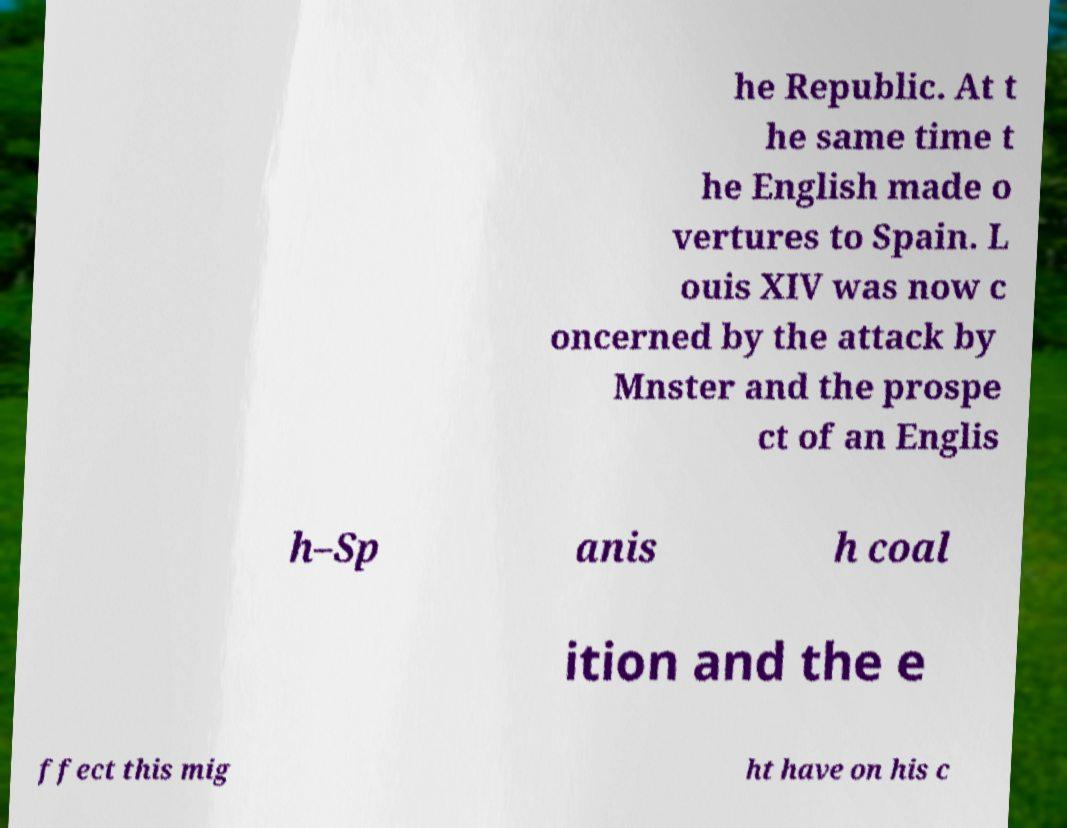There's text embedded in this image that I need extracted. Can you transcribe it verbatim? he Republic. At t he same time t he English made o vertures to Spain. L ouis XIV was now c oncerned by the attack by Mnster and the prospe ct of an Englis h–Sp anis h coal ition and the e ffect this mig ht have on his c 